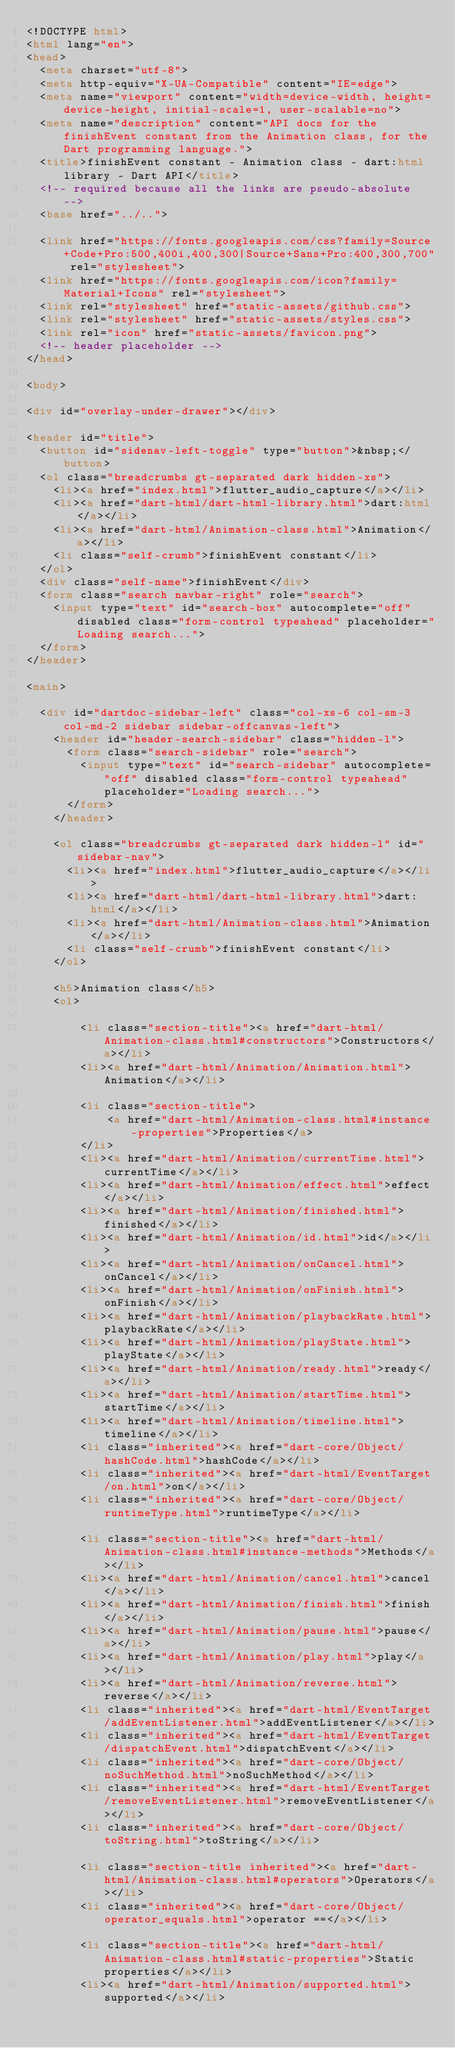<code> <loc_0><loc_0><loc_500><loc_500><_HTML_><!DOCTYPE html>
<html lang="en">
<head>
  <meta charset="utf-8">
  <meta http-equiv="X-UA-Compatible" content="IE=edge">
  <meta name="viewport" content="width=device-width, height=device-height, initial-scale=1, user-scalable=no">
  <meta name="description" content="API docs for the finishEvent constant from the Animation class, for the Dart programming language.">
  <title>finishEvent constant - Animation class - dart:html library - Dart API</title>
  <!-- required because all the links are pseudo-absolute -->
  <base href="../..">

  <link href="https://fonts.googleapis.com/css?family=Source+Code+Pro:500,400i,400,300|Source+Sans+Pro:400,300,700" rel="stylesheet">
  <link href="https://fonts.googleapis.com/icon?family=Material+Icons" rel="stylesheet">
  <link rel="stylesheet" href="static-assets/github.css">
  <link rel="stylesheet" href="static-assets/styles.css">
  <link rel="icon" href="static-assets/favicon.png">
  <!-- header placeholder -->
</head>

<body>

<div id="overlay-under-drawer"></div>

<header id="title">
  <button id="sidenav-left-toggle" type="button">&nbsp;</button>
  <ol class="breadcrumbs gt-separated dark hidden-xs">
    <li><a href="index.html">flutter_audio_capture</a></li>
    <li><a href="dart-html/dart-html-library.html">dart:html</a></li>
    <li><a href="dart-html/Animation-class.html">Animation</a></li>
    <li class="self-crumb">finishEvent constant</li>
  </ol>
  <div class="self-name">finishEvent</div>
  <form class="search navbar-right" role="search">
    <input type="text" id="search-box" autocomplete="off" disabled class="form-control typeahead" placeholder="Loading search...">
  </form>
</header>

<main>

  <div id="dartdoc-sidebar-left" class="col-xs-6 col-sm-3 col-md-2 sidebar sidebar-offcanvas-left">
    <header id="header-search-sidebar" class="hidden-l">
      <form class="search-sidebar" role="search">
        <input type="text" id="search-sidebar" autocomplete="off" disabled class="form-control typeahead" placeholder="Loading search...">
      </form>
    </header>
    
    <ol class="breadcrumbs gt-separated dark hidden-l" id="sidebar-nav">
      <li><a href="index.html">flutter_audio_capture</a></li>
      <li><a href="dart-html/dart-html-library.html">dart:html</a></li>
      <li><a href="dart-html/Animation-class.html">Animation</a></li>
      <li class="self-crumb">finishEvent constant</li>
    </ol>
    
    <h5>Animation class</h5>
    <ol>
    
        <li class="section-title"><a href="dart-html/Animation-class.html#constructors">Constructors</a></li>
        <li><a href="dart-html/Animation/Animation.html">Animation</a></li>
    
        <li class="section-title">
            <a href="dart-html/Animation-class.html#instance-properties">Properties</a>
        </li>
        <li><a href="dart-html/Animation/currentTime.html">currentTime</a></li>
        <li><a href="dart-html/Animation/effect.html">effect</a></li>
        <li><a href="dart-html/Animation/finished.html">finished</a></li>
        <li><a href="dart-html/Animation/id.html">id</a></li>
        <li><a href="dart-html/Animation/onCancel.html">onCancel</a></li>
        <li><a href="dart-html/Animation/onFinish.html">onFinish</a></li>
        <li><a href="dart-html/Animation/playbackRate.html">playbackRate</a></li>
        <li><a href="dart-html/Animation/playState.html">playState</a></li>
        <li><a href="dart-html/Animation/ready.html">ready</a></li>
        <li><a href="dart-html/Animation/startTime.html">startTime</a></li>
        <li><a href="dart-html/Animation/timeline.html">timeline</a></li>
        <li class="inherited"><a href="dart-core/Object/hashCode.html">hashCode</a></li>
        <li class="inherited"><a href="dart-html/EventTarget/on.html">on</a></li>
        <li class="inherited"><a href="dart-core/Object/runtimeType.html">runtimeType</a></li>
    
        <li class="section-title"><a href="dart-html/Animation-class.html#instance-methods">Methods</a></li>
        <li><a href="dart-html/Animation/cancel.html">cancel</a></li>
        <li><a href="dart-html/Animation/finish.html">finish</a></li>
        <li><a href="dart-html/Animation/pause.html">pause</a></li>
        <li><a href="dart-html/Animation/play.html">play</a></li>
        <li><a href="dart-html/Animation/reverse.html">reverse</a></li>
        <li class="inherited"><a href="dart-html/EventTarget/addEventListener.html">addEventListener</a></li>
        <li class="inherited"><a href="dart-html/EventTarget/dispatchEvent.html">dispatchEvent</a></li>
        <li class="inherited"><a href="dart-core/Object/noSuchMethod.html">noSuchMethod</a></li>
        <li class="inherited"><a href="dart-html/EventTarget/removeEventListener.html">removeEventListener</a></li>
        <li class="inherited"><a href="dart-core/Object/toString.html">toString</a></li>
    
        <li class="section-title inherited"><a href="dart-html/Animation-class.html#operators">Operators</a></li>
        <li class="inherited"><a href="dart-core/Object/operator_equals.html">operator ==</a></li>
    
        <li class="section-title"><a href="dart-html/Animation-class.html#static-properties">Static properties</a></li>
        <li><a href="dart-html/Animation/supported.html">supported</a></li>
    
    </code> 